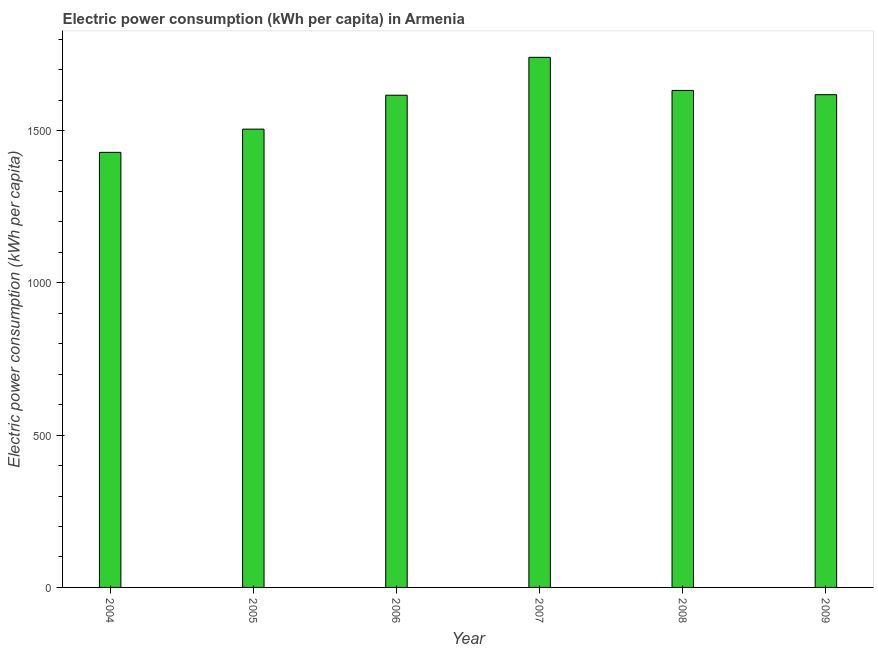What is the title of the graph?
Offer a very short reply. Electric power consumption (kWh per capita) in Armenia. What is the label or title of the Y-axis?
Ensure brevity in your answer.  Electric power consumption (kWh per capita). What is the electric power consumption in 2007?
Your response must be concise. 1740.23. Across all years, what is the maximum electric power consumption?
Your response must be concise. 1740.23. Across all years, what is the minimum electric power consumption?
Ensure brevity in your answer.  1428.3. In which year was the electric power consumption maximum?
Your answer should be compact. 2007. In which year was the electric power consumption minimum?
Make the answer very short. 2004. What is the sum of the electric power consumption?
Ensure brevity in your answer.  9538.07. What is the difference between the electric power consumption in 2007 and 2009?
Your response must be concise. 122.62. What is the average electric power consumption per year?
Make the answer very short. 1589.68. What is the median electric power consumption?
Offer a very short reply. 1616.72. In how many years, is the electric power consumption greater than 1000 kWh per capita?
Your answer should be very brief. 6. What is the ratio of the electric power consumption in 2006 to that in 2007?
Give a very brief answer. 0.93. Is the electric power consumption in 2004 less than that in 2005?
Your answer should be compact. Yes. Is the difference between the electric power consumption in 2004 and 2008 greater than the difference between any two years?
Your answer should be compact. No. What is the difference between the highest and the second highest electric power consumption?
Keep it short and to the point. 108.65. Is the sum of the electric power consumption in 2005 and 2008 greater than the maximum electric power consumption across all years?
Your answer should be very brief. Yes. What is the difference between the highest and the lowest electric power consumption?
Your response must be concise. 311.93. In how many years, is the electric power consumption greater than the average electric power consumption taken over all years?
Make the answer very short. 4. Are all the bars in the graph horizontal?
Ensure brevity in your answer.  No. How many years are there in the graph?
Your response must be concise. 6. Are the values on the major ticks of Y-axis written in scientific E-notation?
Your answer should be very brief. No. What is the Electric power consumption (kWh per capita) of 2004?
Make the answer very short. 1428.3. What is the Electric power consumption (kWh per capita) in 2005?
Provide a short and direct response. 1504.52. What is the Electric power consumption (kWh per capita) in 2006?
Provide a short and direct response. 1615.84. What is the Electric power consumption (kWh per capita) in 2007?
Your answer should be very brief. 1740.23. What is the Electric power consumption (kWh per capita) in 2008?
Make the answer very short. 1631.58. What is the Electric power consumption (kWh per capita) in 2009?
Your answer should be very brief. 1617.61. What is the difference between the Electric power consumption (kWh per capita) in 2004 and 2005?
Give a very brief answer. -76.22. What is the difference between the Electric power consumption (kWh per capita) in 2004 and 2006?
Make the answer very short. -187.54. What is the difference between the Electric power consumption (kWh per capita) in 2004 and 2007?
Your answer should be compact. -311.93. What is the difference between the Electric power consumption (kWh per capita) in 2004 and 2008?
Give a very brief answer. -203.28. What is the difference between the Electric power consumption (kWh per capita) in 2004 and 2009?
Ensure brevity in your answer.  -189.31. What is the difference between the Electric power consumption (kWh per capita) in 2005 and 2006?
Your answer should be very brief. -111.32. What is the difference between the Electric power consumption (kWh per capita) in 2005 and 2007?
Offer a terse response. -235.71. What is the difference between the Electric power consumption (kWh per capita) in 2005 and 2008?
Offer a very short reply. -127.06. What is the difference between the Electric power consumption (kWh per capita) in 2005 and 2009?
Make the answer very short. -113.09. What is the difference between the Electric power consumption (kWh per capita) in 2006 and 2007?
Keep it short and to the point. -124.39. What is the difference between the Electric power consumption (kWh per capita) in 2006 and 2008?
Your answer should be very brief. -15.74. What is the difference between the Electric power consumption (kWh per capita) in 2006 and 2009?
Keep it short and to the point. -1.77. What is the difference between the Electric power consumption (kWh per capita) in 2007 and 2008?
Give a very brief answer. 108.65. What is the difference between the Electric power consumption (kWh per capita) in 2007 and 2009?
Your answer should be very brief. 122.62. What is the difference between the Electric power consumption (kWh per capita) in 2008 and 2009?
Your answer should be very brief. 13.97. What is the ratio of the Electric power consumption (kWh per capita) in 2004 to that in 2005?
Your answer should be compact. 0.95. What is the ratio of the Electric power consumption (kWh per capita) in 2004 to that in 2006?
Give a very brief answer. 0.88. What is the ratio of the Electric power consumption (kWh per capita) in 2004 to that in 2007?
Your response must be concise. 0.82. What is the ratio of the Electric power consumption (kWh per capita) in 2004 to that in 2009?
Offer a very short reply. 0.88. What is the ratio of the Electric power consumption (kWh per capita) in 2005 to that in 2006?
Provide a succinct answer. 0.93. What is the ratio of the Electric power consumption (kWh per capita) in 2005 to that in 2007?
Your answer should be very brief. 0.86. What is the ratio of the Electric power consumption (kWh per capita) in 2005 to that in 2008?
Your response must be concise. 0.92. What is the ratio of the Electric power consumption (kWh per capita) in 2005 to that in 2009?
Give a very brief answer. 0.93. What is the ratio of the Electric power consumption (kWh per capita) in 2006 to that in 2007?
Your response must be concise. 0.93. What is the ratio of the Electric power consumption (kWh per capita) in 2006 to that in 2008?
Offer a terse response. 0.99. What is the ratio of the Electric power consumption (kWh per capita) in 2006 to that in 2009?
Keep it short and to the point. 1. What is the ratio of the Electric power consumption (kWh per capita) in 2007 to that in 2008?
Make the answer very short. 1.07. What is the ratio of the Electric power consumption (kWh per capita) in 2007 to that in 2009?
Keep it short and to the point. 1.08. What is the ratio of the Electric power consumption (kWh per capita) in 2008 to that in 2009?
Your response must be concise. 1.01. 